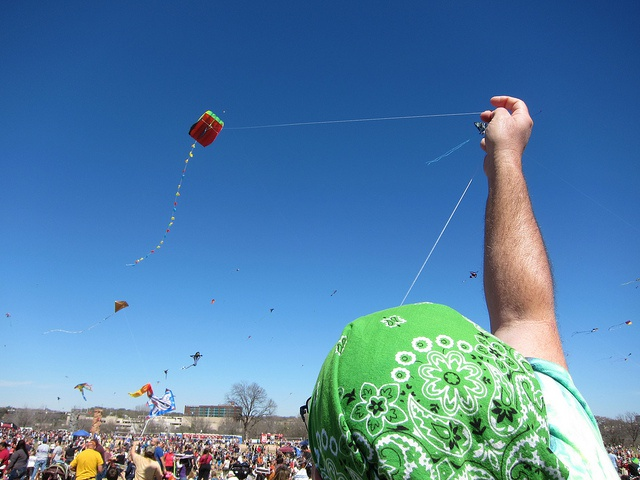Describe the objects in this image and their specific colors. I can see people in darkblue, white, lightgreen, green, and tan tones, people in darkblue, gray, darkgray, and black tones, kite in darkblue, maroon, blue, brown, and gray tones, people in darkblue, orange, gold, and salmon tones, and kite in darkblue, lavender, lightblue, and darkgray tones in this image. 